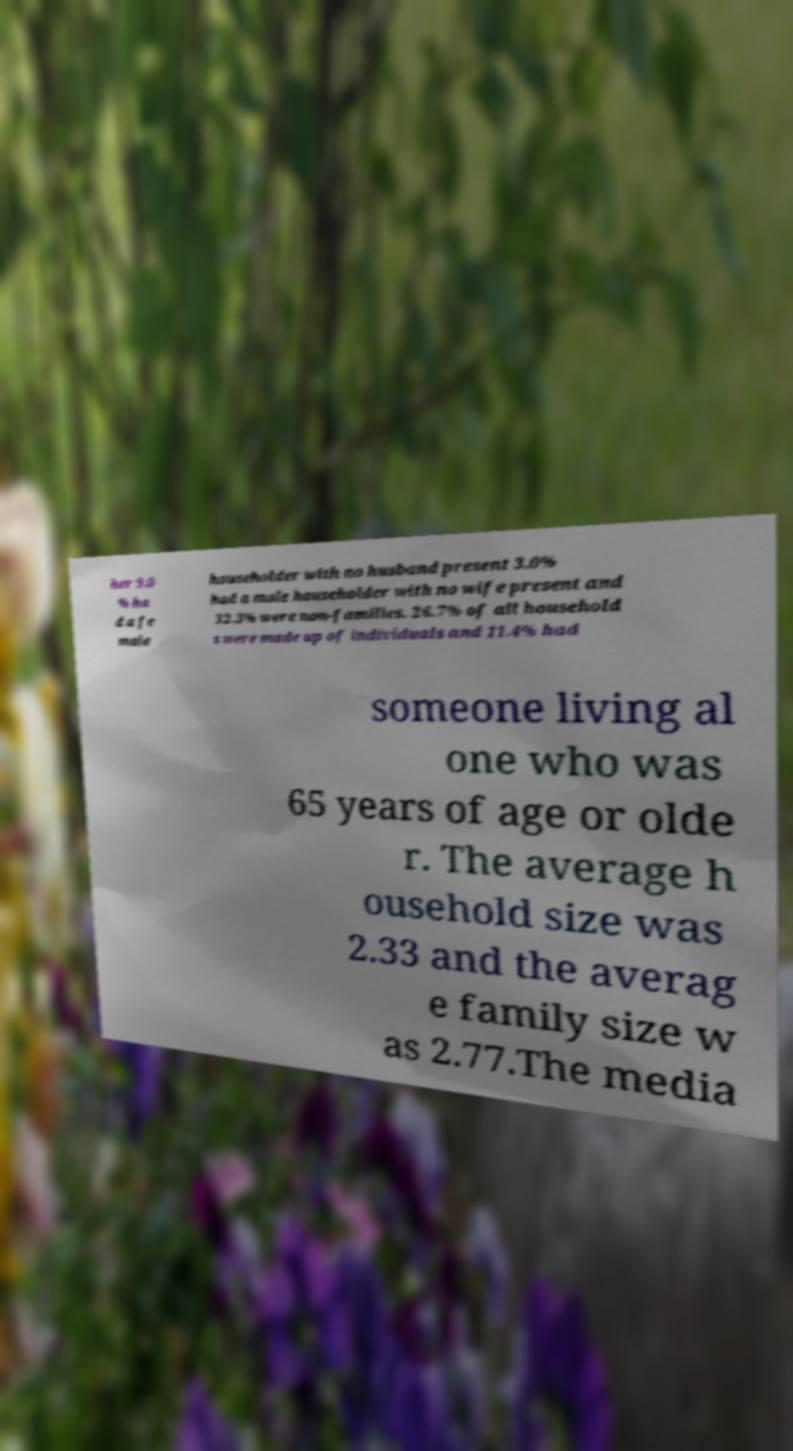Can you read and provide the text displayed in the image?This photo seems to have some interesting text. Can you extract and type it out for me? her 9.0 % ha d a fe male householder with no husband present 3.0% had a male householder with no wife present and 32.3% were non-families. 26.7% of all household s were made up of individuals and 11.4% had someone living al one who was 65 years of age or olde r. The average h ousehold size was 2.33 and the averag e family size w as 2.77.The media 